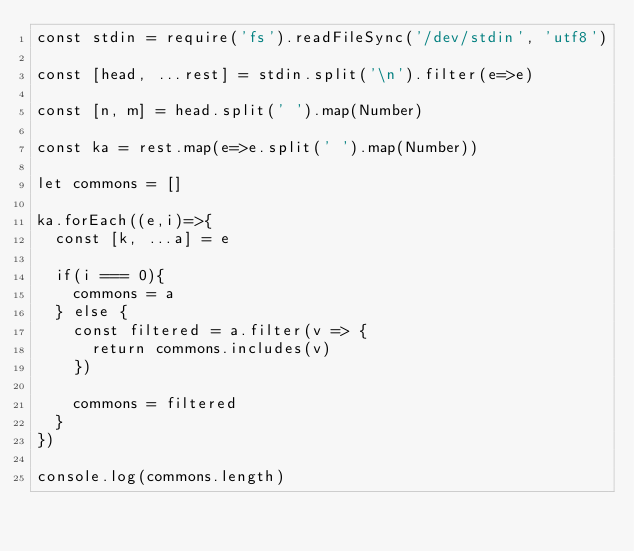<code> <loc_0><loc_0><loc_500><loc_500><_TypeScript_>const stdin = require('fs').readFileSync('/dev/stdin', 'utf8')

const [head, ...rest] = stdin.split('\n').filter(e=>e)

const [n, m] = head.split(' ').map(Number)

const ka = rest.map(e=>e.split(' ').map(Number))

let commons = []

ka.forEach((e,i)=>{
  const [k, ...a] = e
  
  if(i === 0){
    commons = a
  } else {
    const filtered = a.filter(v => {
      return commons.includes(v)
    })

    commons = filtered
  }
})

console.log(commons.length)</code> 